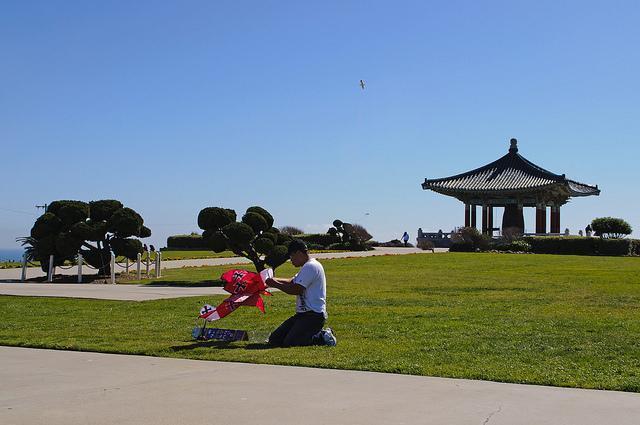How many women in the photo?
Give a very brief answer. 0. How many black donut are there this images?
Give a very brief answer. 0. 